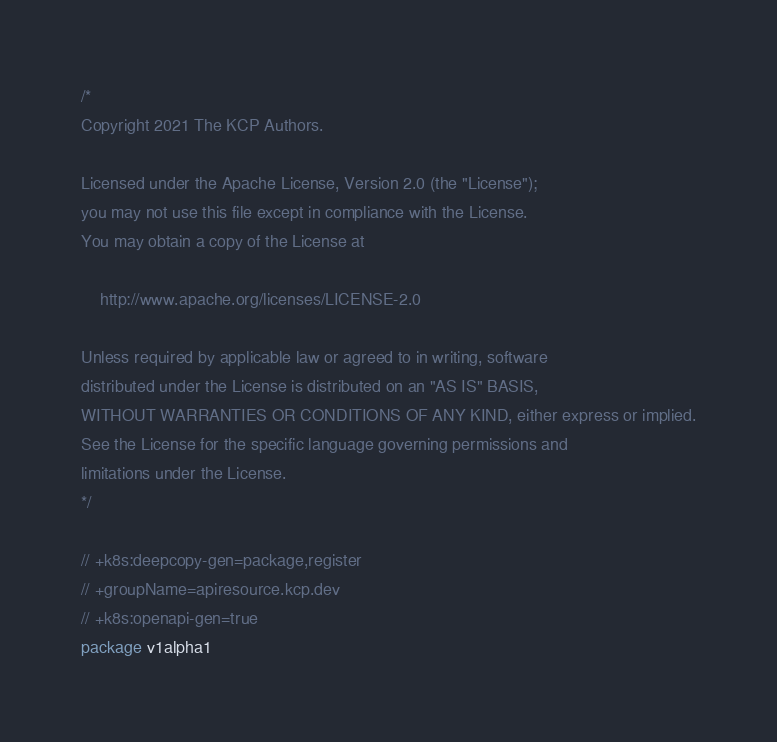Convert code to text. <code><loc_0><loc_0><loc_500><loc_500><_Go_>/*
Copyright 2021 The KCP Authors.

Licensed under the Apache License, Version 2.0 (the "License");
you may not use this file except in compliance with the License.
You may obtain a copy of the License at

    http://www.apache.org/licenses/LICENSE-2.0

Unless required by applicable law or agreed to in writing, software
distributed under the License is distributed on an "AS IS" BASIS,
WITHOUT WARRANTIES OR CONDITIONS OF ANY KIND, either express or implied.
See the License for the specific language governing permissions and
limitations under the License.
*/

// +k8s:deepcopy-gen=package,register
// +groupName=apiresource.kcp.dev
// +k8s:openapi-gen=true
package v1alpha1
</code> 